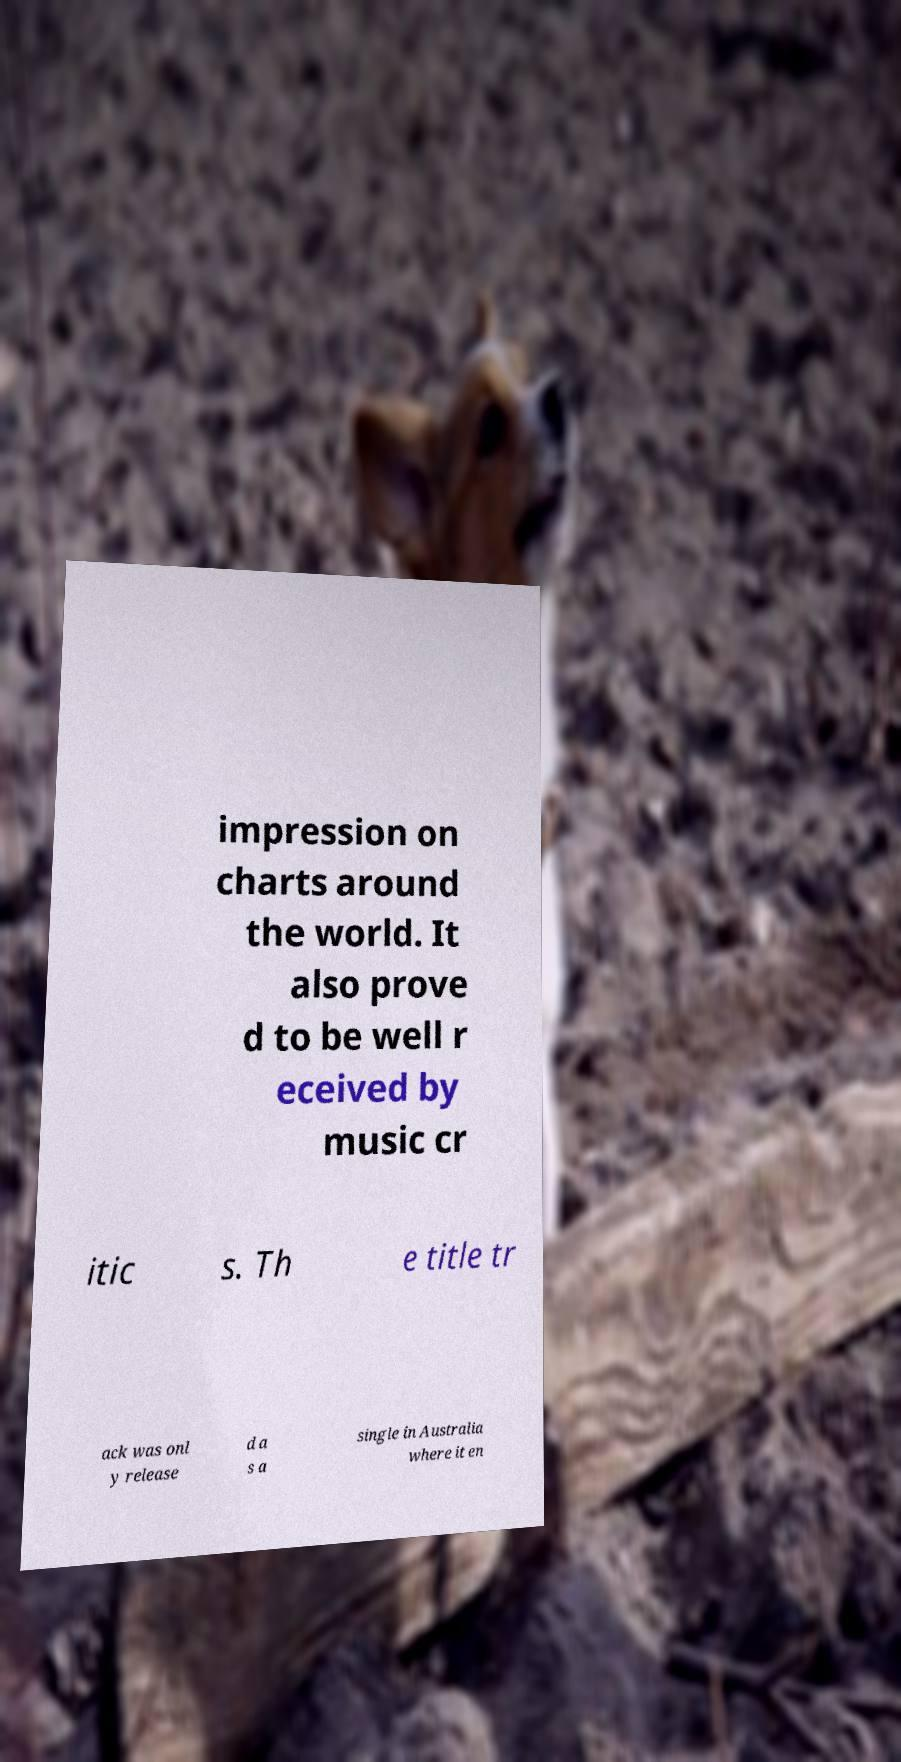Can you accurately transcribe the text from the provided image for me? impression on charts around the world. It also prove d to be well r eceived by music cr itic s. Th e title tr ack was onl y release d a s a single in Australia where it en 